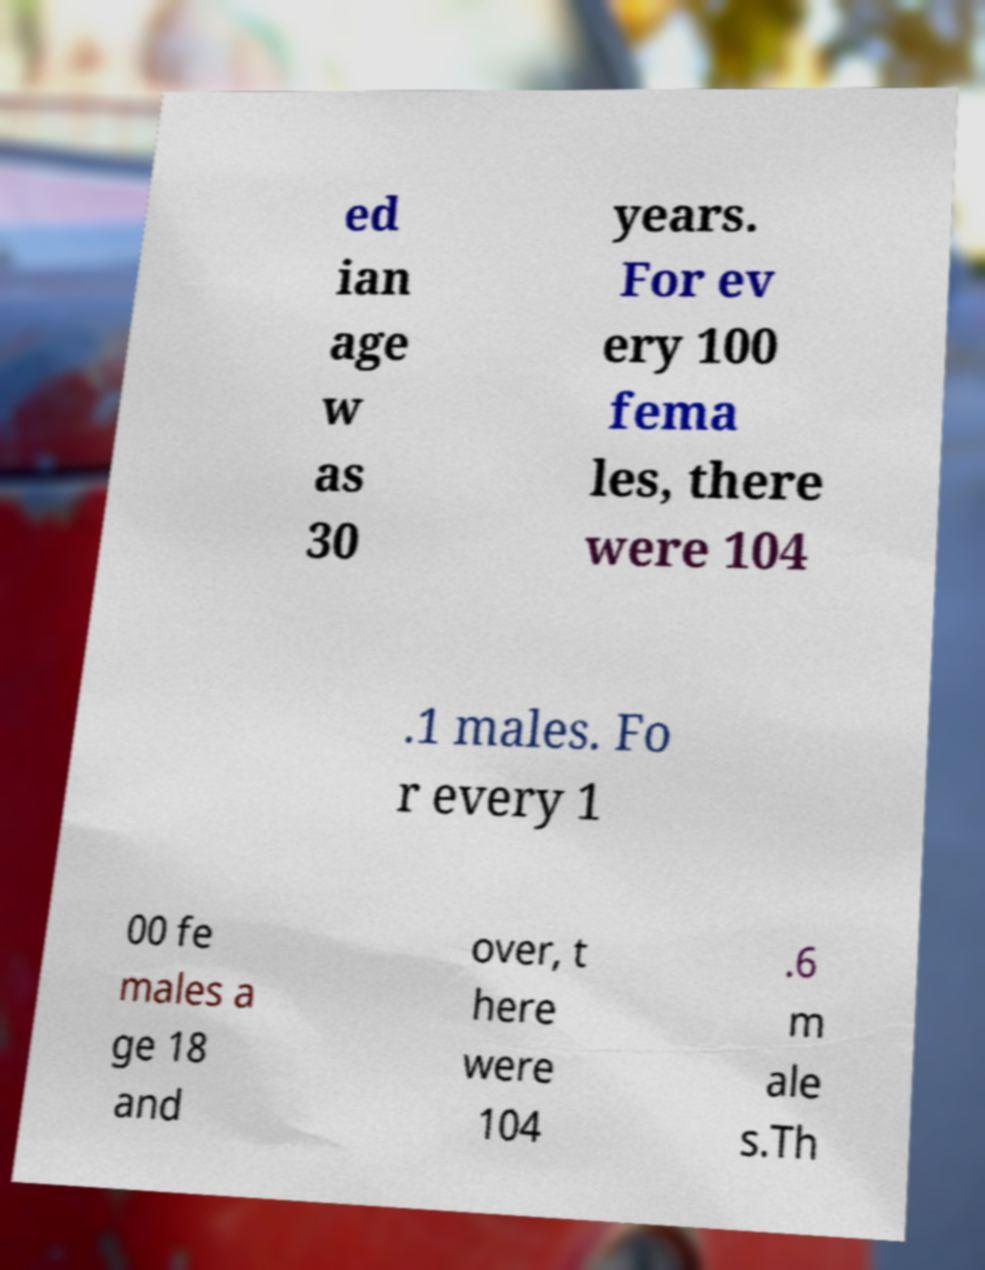What messages or text are displayed in this image? I need them in a readable, typed format. ed ian age w as 30 years. For ev ery 100 fema les, there were 104 .1 males. Fo r every 1 00 fe males a ge 18 and over, t here were 104 .6 m ale s.Th 